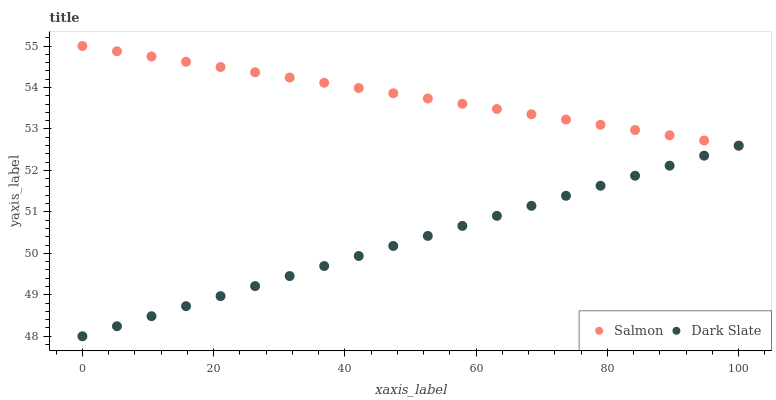Does Dark Slate have the minimum area under the curve?
Answer yes or no. Yes. Does Salmon have the maximum area under the curve?
Answer yes or no. Yes. Does Salmon have the minimum area under the curve?
Answer yes or no. No. Is Dark Slate the smoothest?
Answer yes or no. Yes. Is Salmon the roughest?
Answer yes or no. Yes. Is Salmon the smoothest?
Answer yes or no. No. Does Dark Slate have the lowest value?
Answer yes or no. Yes. Does Salmon have the lowest value?
Answer yes or no. No. Does Salmon have the highest value?
Answer yes or no. Yes. Does Dark Slate intersect Salmon?
Answer yes or no. Yes. Is Dark Slate less than Salmon?
Answer yes or no. No. Is Dark Slate greater than Salmon?
Answer yes or no. No. 